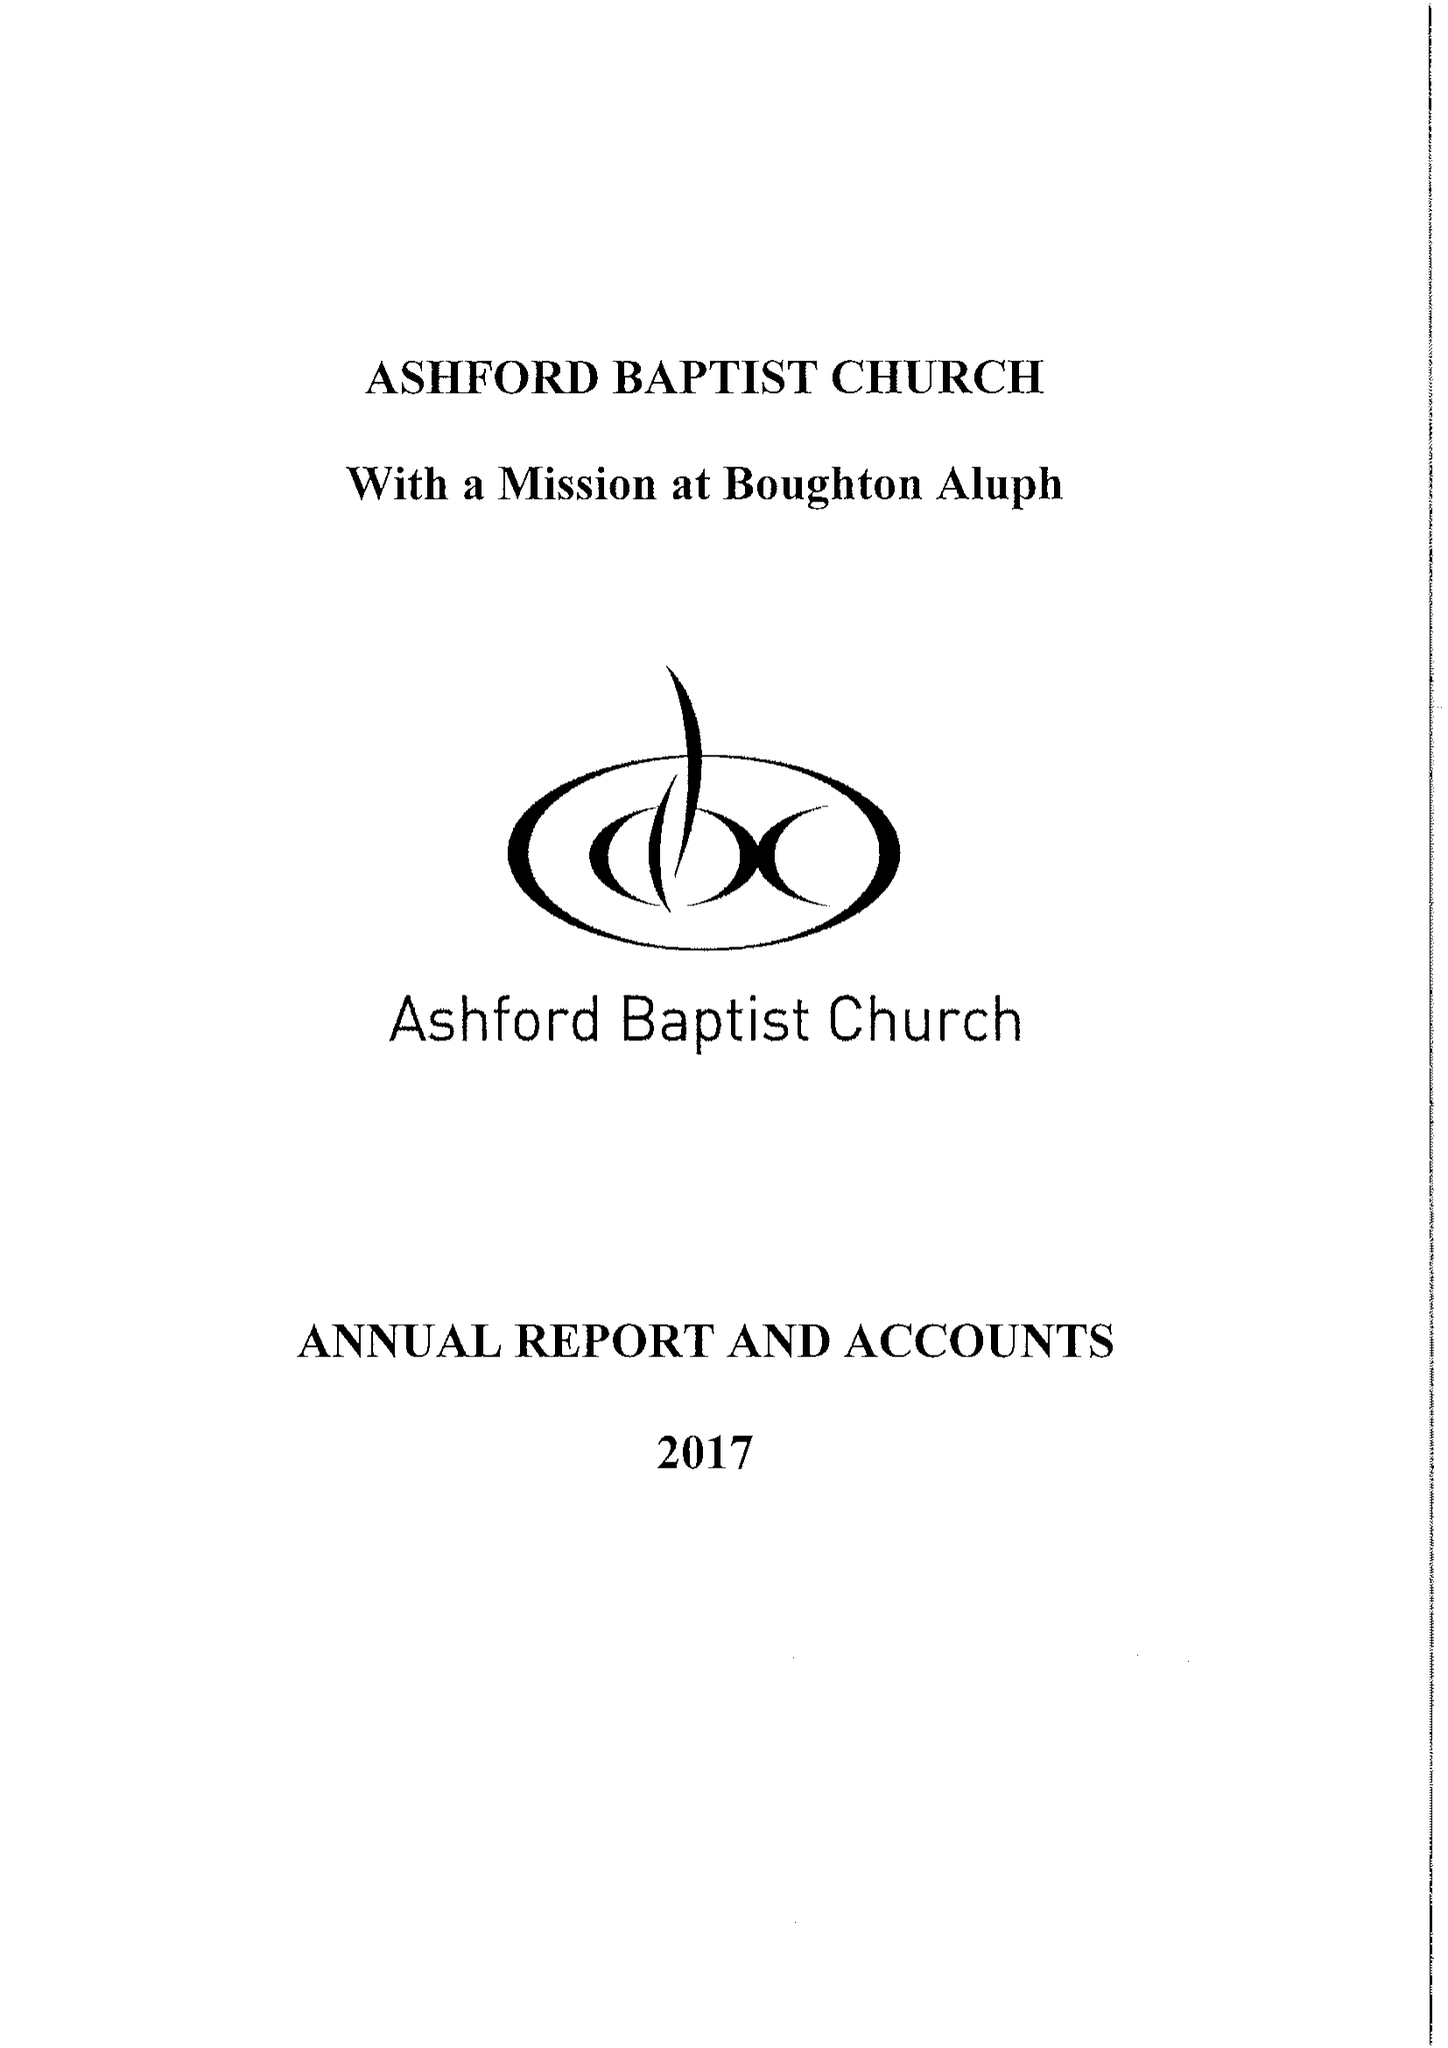What is the value for the address__postcode?
Answer the question using a single word or phrase. TN23 1PS 